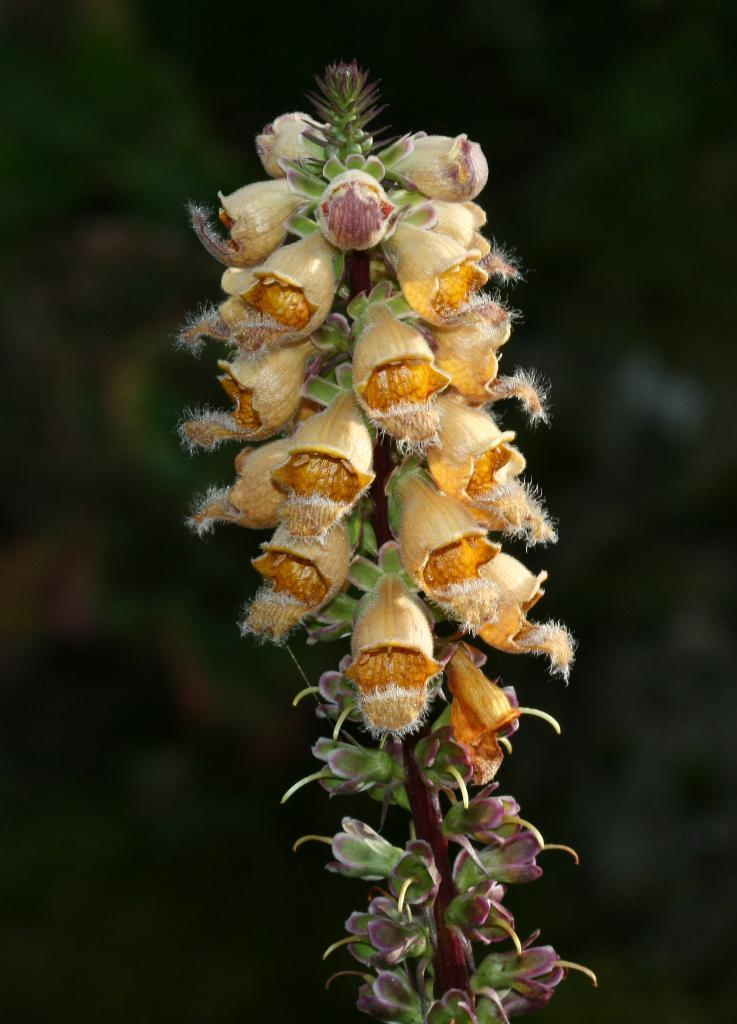What is the main subject of the image? The main subject of the image is a branch of flowers. Can you describe the background of the image? The flowers are on a dark background. What type of grain can be seen in the image? There is no grain present in the image; it features a branch of flowers on a dark background. Can you tell me how many porters are carrying the tub in the image? There is no tub or porter present in the image. 